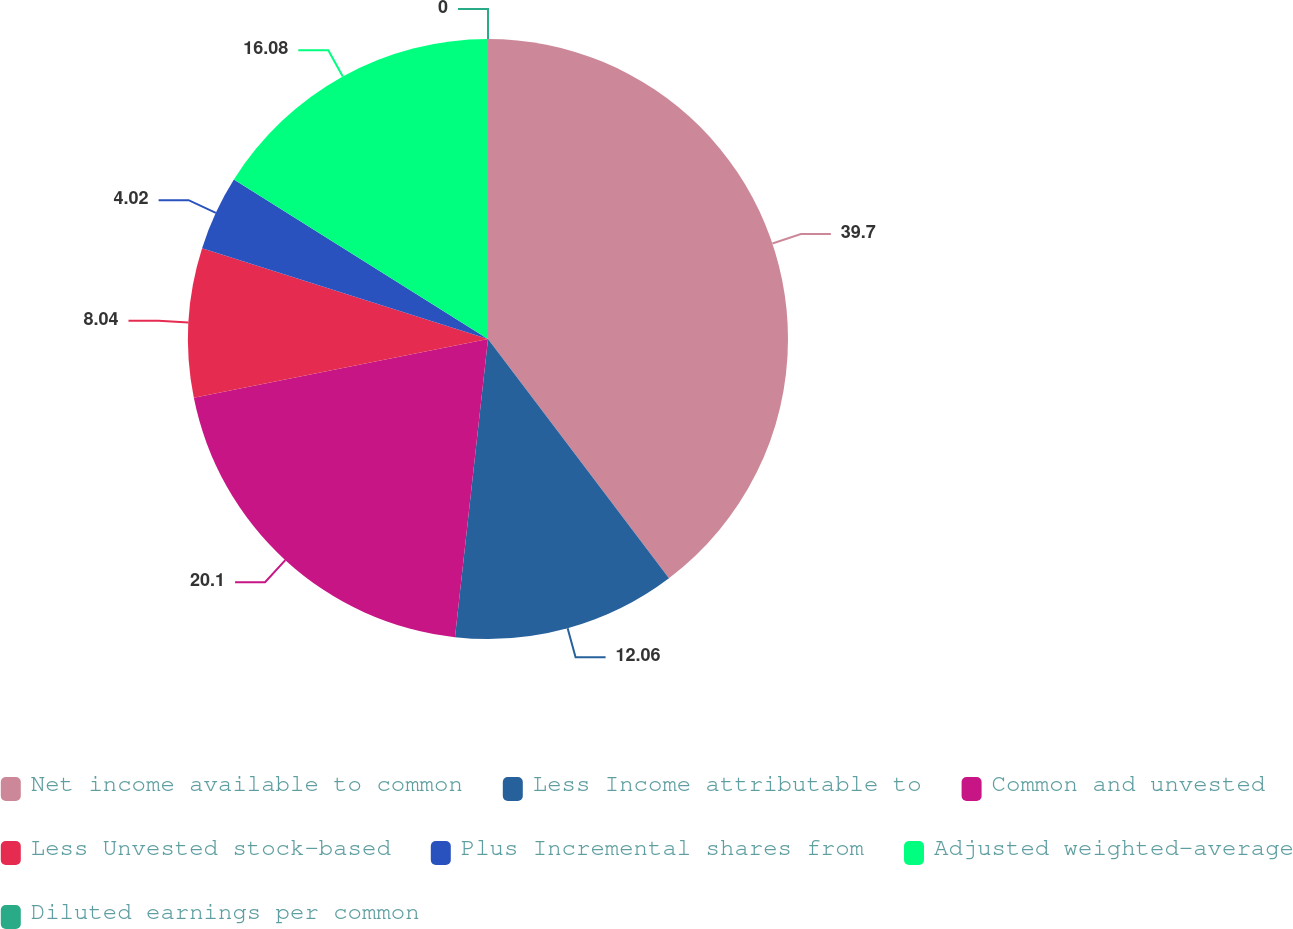<chart> <loc_0><loc_0><loc_500><loc_500><pie_chart><fcel>Net income available to common<fcel>Less Income attributable to<fcel>Common and unvested<fcel>Less Unvested stock-based<fcel>Plus Incremental shares from<fcel>Adjusted weighted-average<fcel>Diluted earnings per common<nl><fcel>39.69%<fcel>12.06%<fcel>20.1%<fcel>8.04%<fcel>4.02%<fcel>16.08%<fcel>0.0%<nl></chart> 